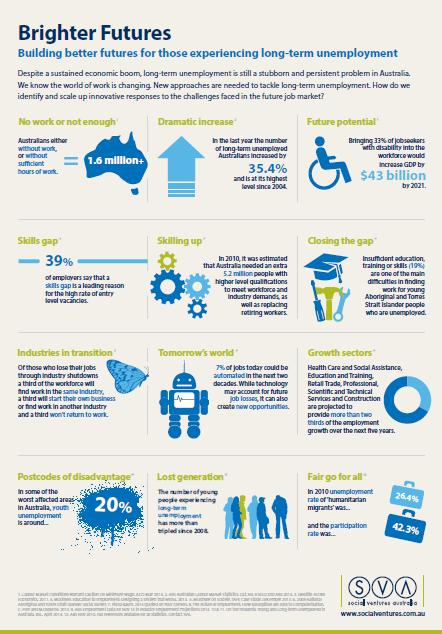Mention a couple of crucial points in this snapshot. In 2010, the unemployment rate and participation rate were two key indicators of the health of the labor market. The unemployment rate, which measures the percentage of the labor force that is without employment, was 9.6%, while the participation rate, which measures the percentage of the population that is actively participating in the labor force, was 65.7%. It is estimated that 33% of individuals with disabilities need to be brought back into the workforce in order to achieve full employment for people with disabilities. The robot in tomorrow's world will show the area. It is estimated that over 1.6 million people are currently without work or not having enough work. The butterfly represents industries undergoing transition. 